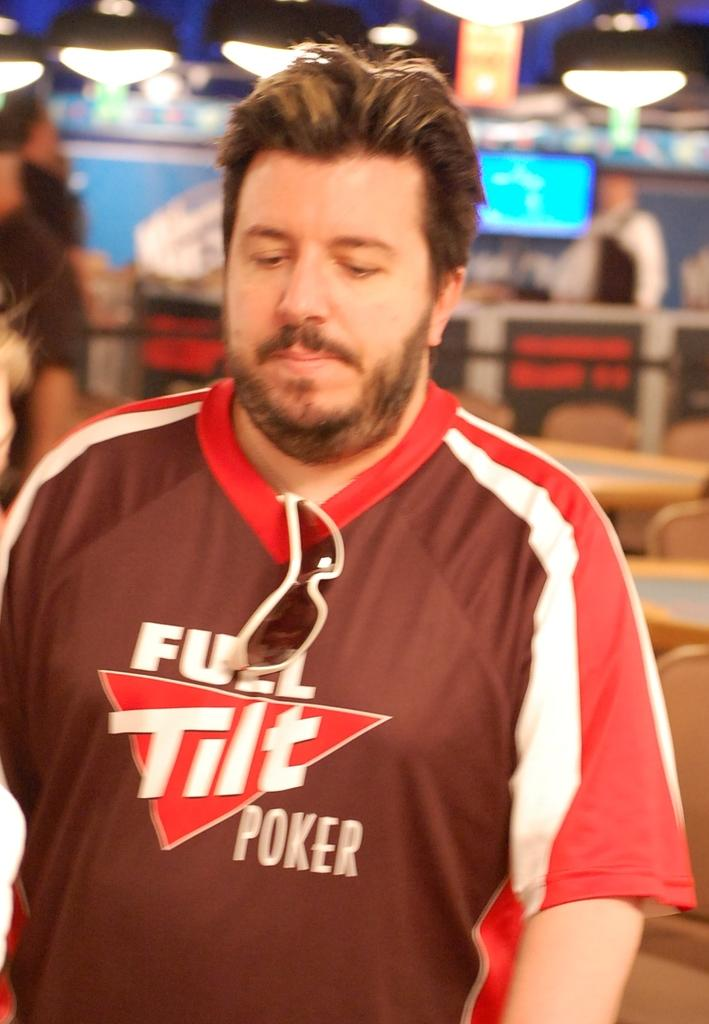<image>
Write a terse but informative summary of the picture. A man wearing a full tilt poker shirt looks sad. 